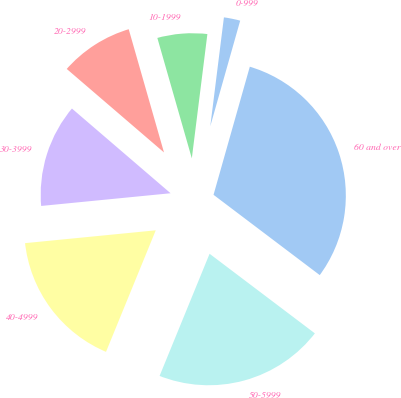Convert chart to OTSL. <chart><loc_0><loc_0><loc_500><loc_500><pie_chart><fcel>0-999<fcel>10-1999<fcel>20-2999<fcel>30-3999<fcel>40-4999<fcel>50-5999<fcel>60 and over<nl><fcel>2.41%<fcel>6.42%<fcel>9.27%<fcel>12.85%<fcel>17.26%<fcel>20.88%<fcel>30.91%<nl></chart> 